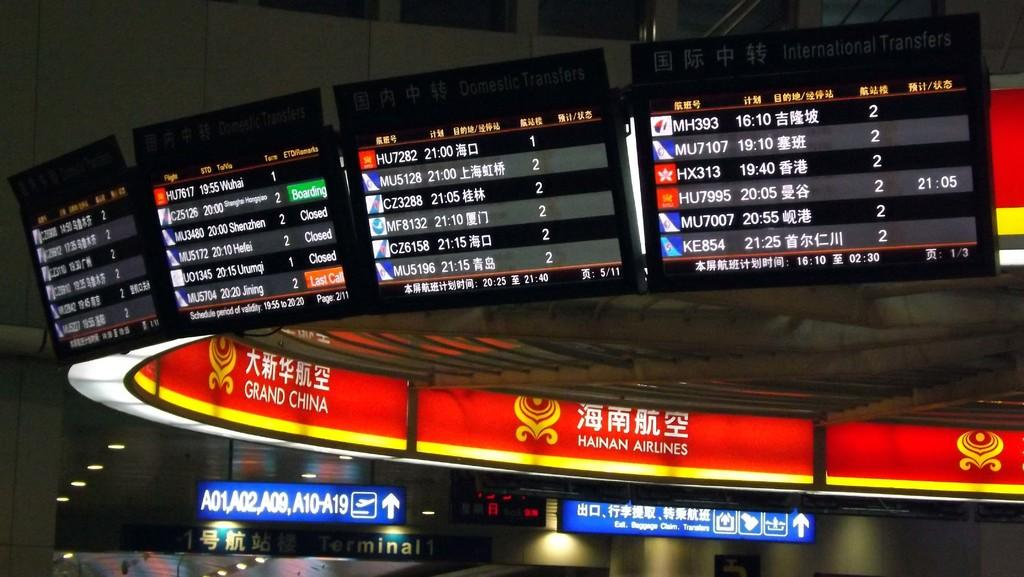<image>
Summarize the visual content of the image. The top flight on the far right board is flight MH393 